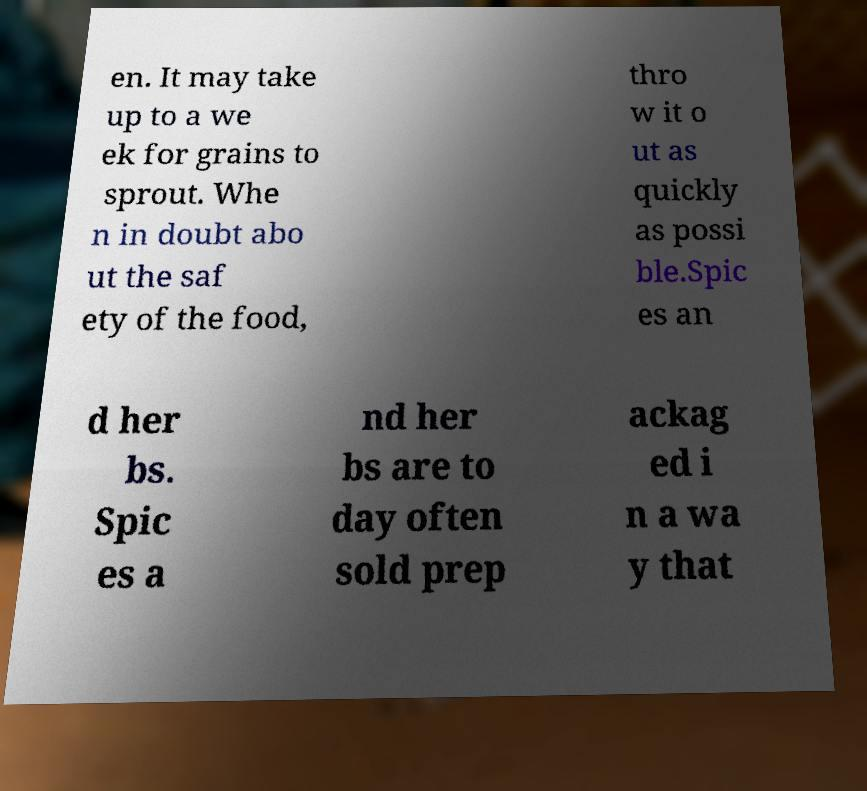Could you extract and type out the text from this image? en. It may take up to a we ek for grains to sprout. Whe n in doubt abo ut the saf ety of the food, thro w it o ut as quickly as possi ble.Spic es an d her bs. Spic es a nd her bs are to day often sold prep ackag ed i n a wa y that 